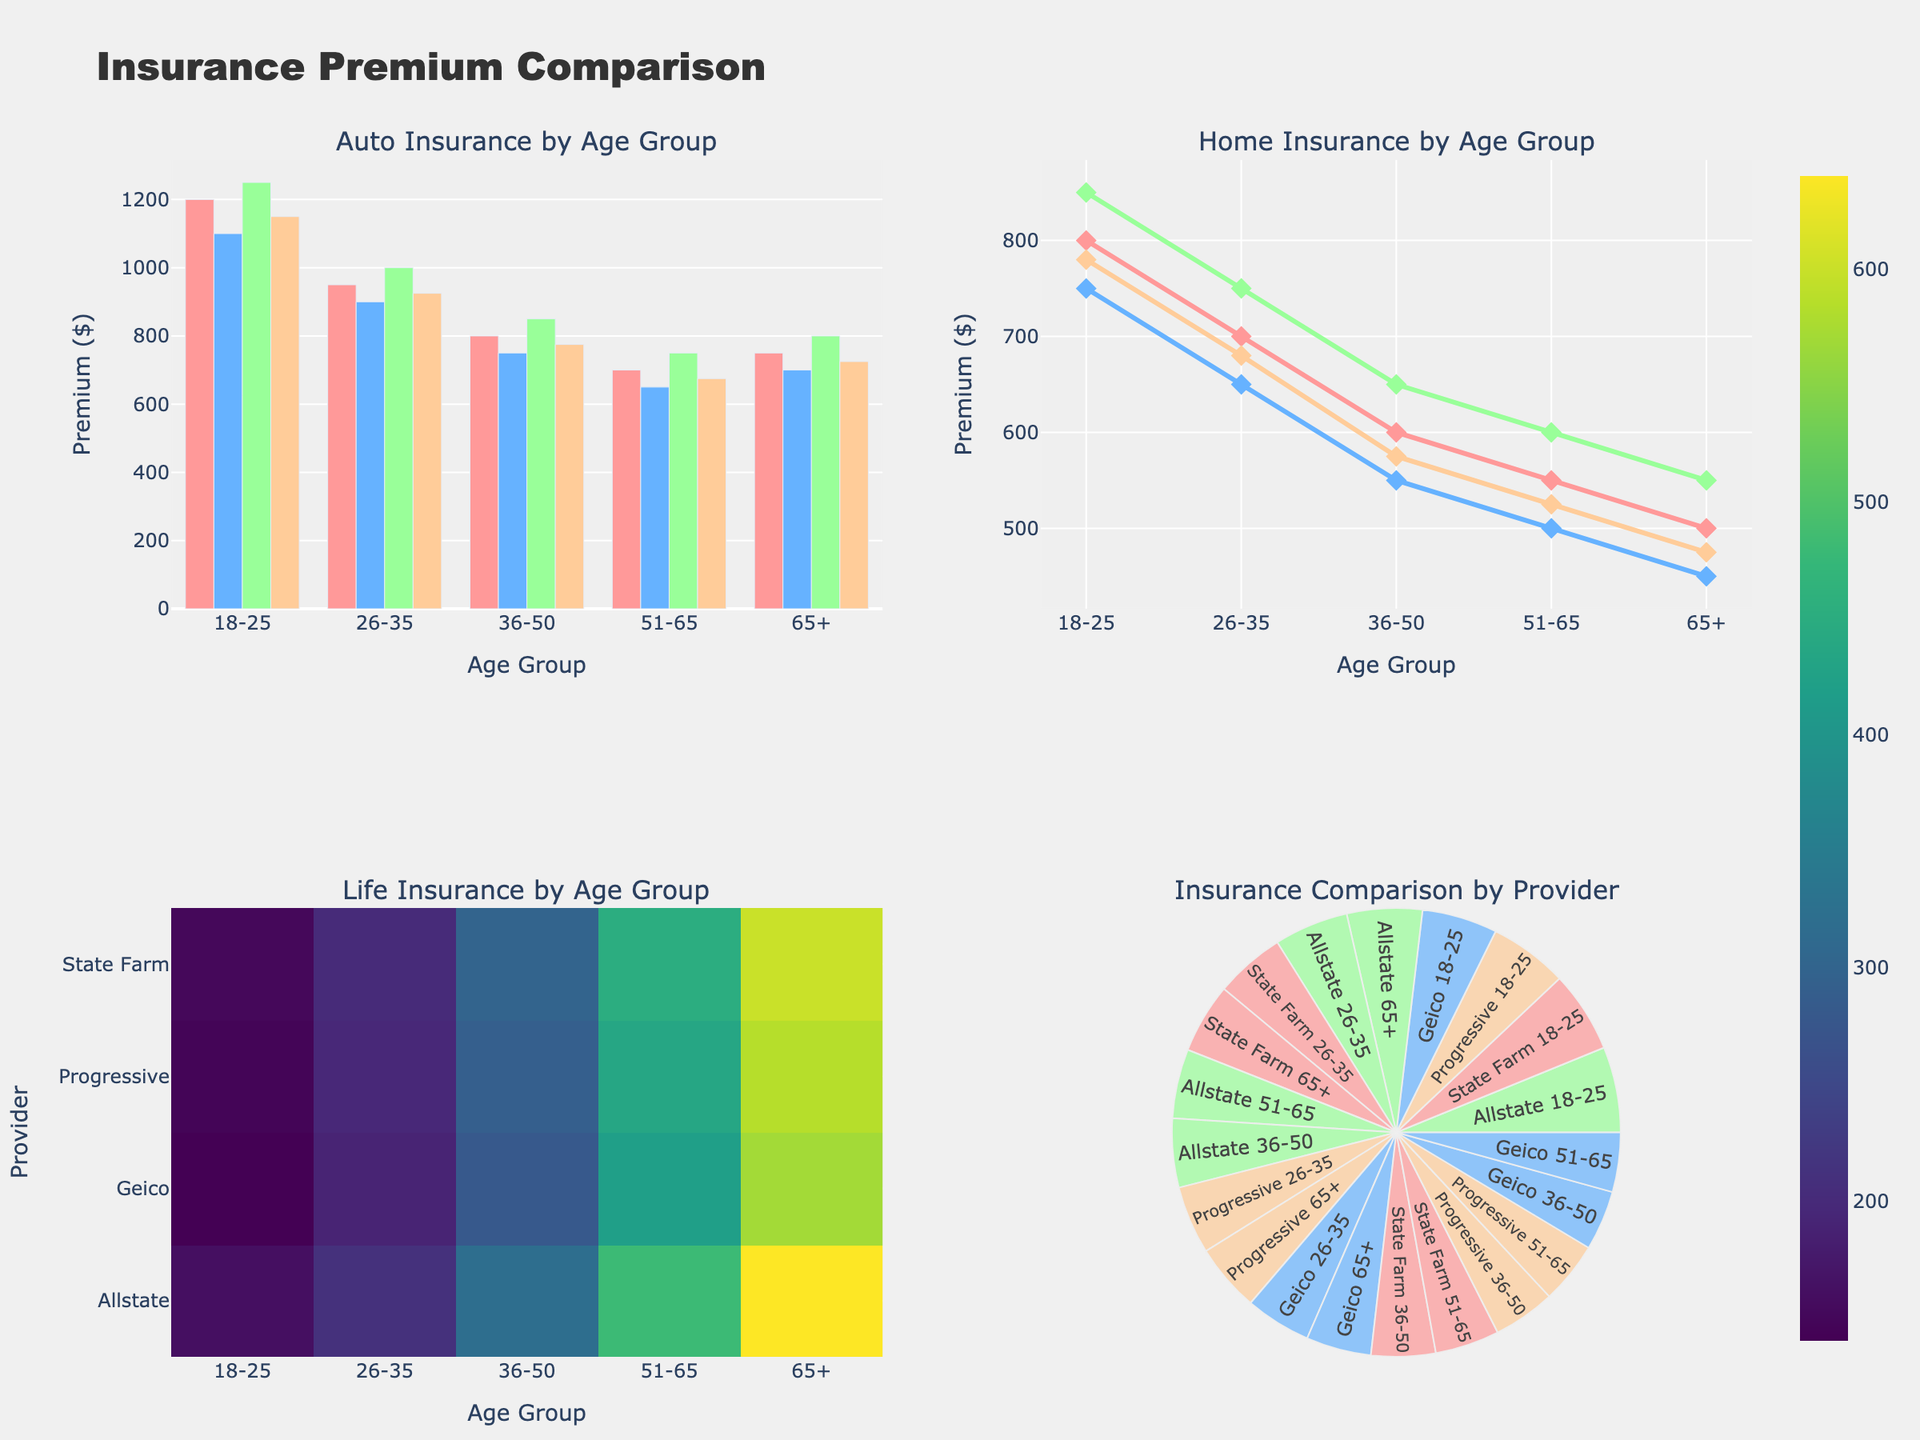what is the title of the figure? The title of the figure is typically found at the top, centered above all the subplots. According to the layout update, the title text in this figure is "Insurance Premium Comparison".
Answer: Insurance Premium Comparison What color represents Geico in the Auto Insurance bar chart? Each provider in the Auto Insurance bar chart is represented by a specific color, and Geico is represented with a shade of blue (#66B2FF in the code).
Answer: Blue Which age group has the highest Auto Insurance premium for Allstate? In the Auto Insurance bar chart on the top left, you can visually compare the bars for Allstate across different age groups. The tallest bar for Allstate is for the 18-25 age group with a premium of 1250.
Answer: 18-25 How does the Life Insurance premium for Progressive change across different age groups? The Life Insurance premiums can be checked on the heatmap. In the row corresponding to Progressive, the values increase from 145 at 18-25 to 585 at 65+.
Answer: It increases Which provider has the lowest Home Insurance premium for the 36-50 age group? In the Home Insurance line chart on the top right, look for the lowest point among the providers in the 36-50 age group. Geico has the lowest premium with a value of 550.
Answer: Geico What is the total insurance cost for State Farm for the age group 51-65? Add the premiums for Auto Insurance, Home Insurance, and Life Insurance for State Farm in the 51-65 age group: 700 + 550 + 450 = 1700.
Answer: 1700 Compare Auto Insurance premiums for 26-35: Is Progressive cheaper than Allstate? In the Auto Insurance bar chart on the top left, compare the height of the bars for Progressive and Allstate in the 26-35 age group. Progressive has a premium of 925 while Allstate has a premium of 1000. So, Progressive is cheaper.
Answer: Yes From the Sunburst chart, which age group and provider combination has the highest total premium? In the Sunburst chart on the bottom right, the size of the segment symbolizes the total premium. The largest segment is for Allstate 65+ with a value encompassing Auto, Home and Life premiums.
Answer: Allstate 65+ Is the trend of Home Insurance premiums rising or falling as age increases? By observing the line chart of Home Insurance premiums by age group (top right), the trend for most providers shows declining premiums as age increases.
Answer: Falling Which provider stands out the most in the Life Insurance heatmap and why? In the Life Insurance heatmap (bottom left), Allstate stands out with the brightest color for the 65+ age group, indicating the highest premium value of 640.
Answer: Allstate 